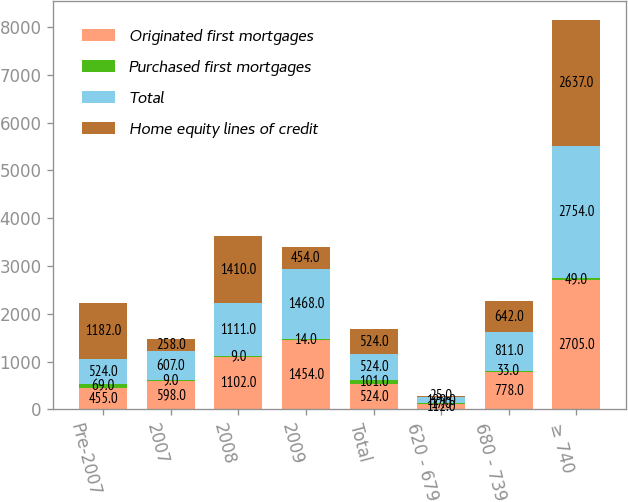<chart> <loc_0><loc_0><loc_500><loc_500><stacked_bar_chart><ecel><fcel>Pre-2007<fcel>2007<fcel>2008<fcel>2009<fcel>Total<fcel>620 - 679<fcel>680 - 739<fcel>≥ 740<nl><fcel>Originated first mortgages<fcel>455<fcel>598<fcel>1102<fcel>1454<fcel>524<fcel>112<fcel>778<fcel>2705<nl><fcel>Purchased first mortgages<fcel>69<fcel>9<fcel>9<fcel>14<fcel>101<fcel>17<fcel>33<fcel>49<nl><fcel>Total<fcel>524<fcel>607<fcel>1111<fcel>1468<fcel>524<fcel>129<fcel>811<fcel>2754<nl><fcel>Home equity lines of credit<fcel>1182<fcel>258<fcel>1410<fcel>454<fcel>524<fcel>25<fcel>642<fcel>2637<nl></chart> 